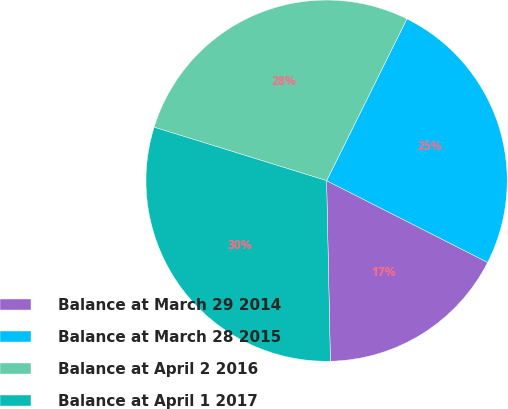<chart> <loc_0><loc_0><loc_500><loc_500><pie_chart><fcel>Balance at March 29 2014<fcel>Balance at March 28 2015<fcel>Balance at April 2 2016<fcel>Balance at April 1 2017<nl><fcel>17.19%<fcel>25.14%<fcel>27.55%<fcel>30.12%<nl></chart> 